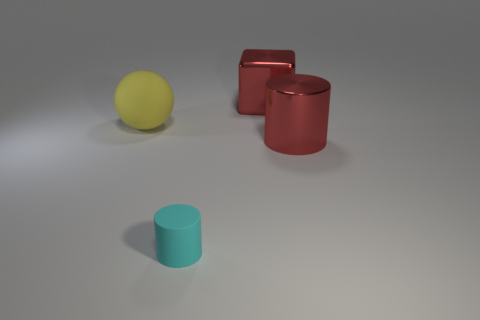Are there any matte things of the same size as the red shiny cylinder?
Provide a succinct answer. Yes. The block that is made of the same material as the red cylinder is what size?
Your answer should be very brief. Large. The tiny rubber object is what shape?
Your response must be concise. Cylinder. Does the yellow sphere have the same material as the red object that is behind the large shiny cylinder?
Offer a very short reply. No. What number of things are either yellow balls or large purple metallic objects?
Make the answer very short. 1. Are there any large gray metallic balls?
Offer a very short reply. No. The red object that is behind the large object in front of the sphere is what shape?
Your answer should be compact. Cube. How many things are either big red objects that are behind the big red cylinder or large red shiny objects behind the big yellow matte sphere?
Ensure brevity in your answer.  1. What is the material of the yellow sphere that is the same size as the red cylinder?
Keep it short and to the point. Rubber. The large matte object is what color?
Keep it short and to the point. Yellow. 